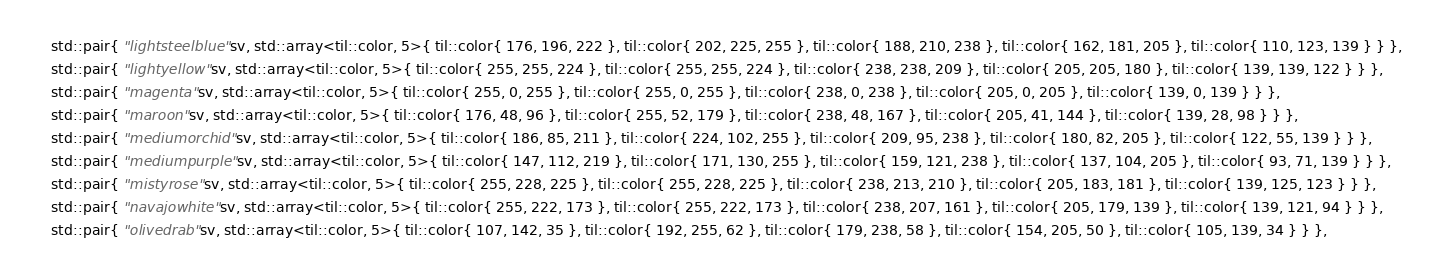Convert code to text. <code><loc_0><loc_0><loc_500><loc_500><_C++_>    std::pair{ "lightsteelblue"sv, std::array<til::color, 5>{ til::color{ 176, 196, 222 }, til::color{ 202, 225, 255 }, til::color{ 188, 210, 238 }, til::color{ 162, 181, 205 }, til::color{ 110, 123, 139 } } },
    std::pair{ "lightyellow"sv, std::array<til::color, 5>{ til::color{ 255, 255, 224 }, til::color{ 255, 255, 224 }, til::color{ 238, 238, 209 }, til::color{ 205, 205, 180 }, til::color{ 139, 139, 122 } } },
    std::pair{ "magenta"sv, std::array<til::color, 5>{ til::color{ 255, 0, 255 }, til::color{ 255, 0, 255 }, til::color{ 238, 0, 238 }, til::color{ 205, 0, 205 }, til::color{ 139, 0, 139 } } },
    std::pair{ "maroon"sv, std::array<til::color, 5>{ til::color{ 176, 48, 96 }, til::color{ 255, 52, 179 }, til::color{ 238, 48, 167 }, til::color{ 205, 41, 144 }, til::color{ 139, 28, 98 } } },
    std::pair{ "mediumorchid"sv, std::array<til::color, 5>{ til::color{ 186, 85, 211 }, til::color{ 224, 102, 255 }, til::color{ 209, 95, 238 }, til::color{ 180, 82, 205 }, til::color{ 122, 55, 139 } } },
    std::pair{ "mediumpurple"sv, std::array<til::color, 5>{ til::color{ 147, 112, 219 }, til::color{ 171, 130, 255 }, til::color{ 159, 121, 238 }, til::color{ 137, 104, 205 }, til::color{ 93, 71, 139 } } },
    std::pair{ "mistyrose"sv, std::array<til::color, 5>{ til::color{ 255, 228, 225 }, til::color{ 255, 228, 225 }, til::color{ 238, 213, 210 }, til::color{ 205, 183, 181 }, til::color{ 139, 125, 123 } } },
    std::pair{ "navajowhite"sv, std::array<til::color, 5>{ til::color{ 255, 222, 173 }, til::color{ 255, 222, 173 }, til::color{ 238, 207, 161 }, til::color{ 205, 179, 139 }, til::color{ 139, 121, 94 } } },
    std::pair{ "olivedrab"sv, std::array<til::color, 5>{ til::color{ 107, 142, 35 }, til::color{ 192, 255, 62 }, til::color{ 179, 238, 58 }, til::color{ 154, 205, 50 }, til::color{ 105, 139, 34 } } },</code> 